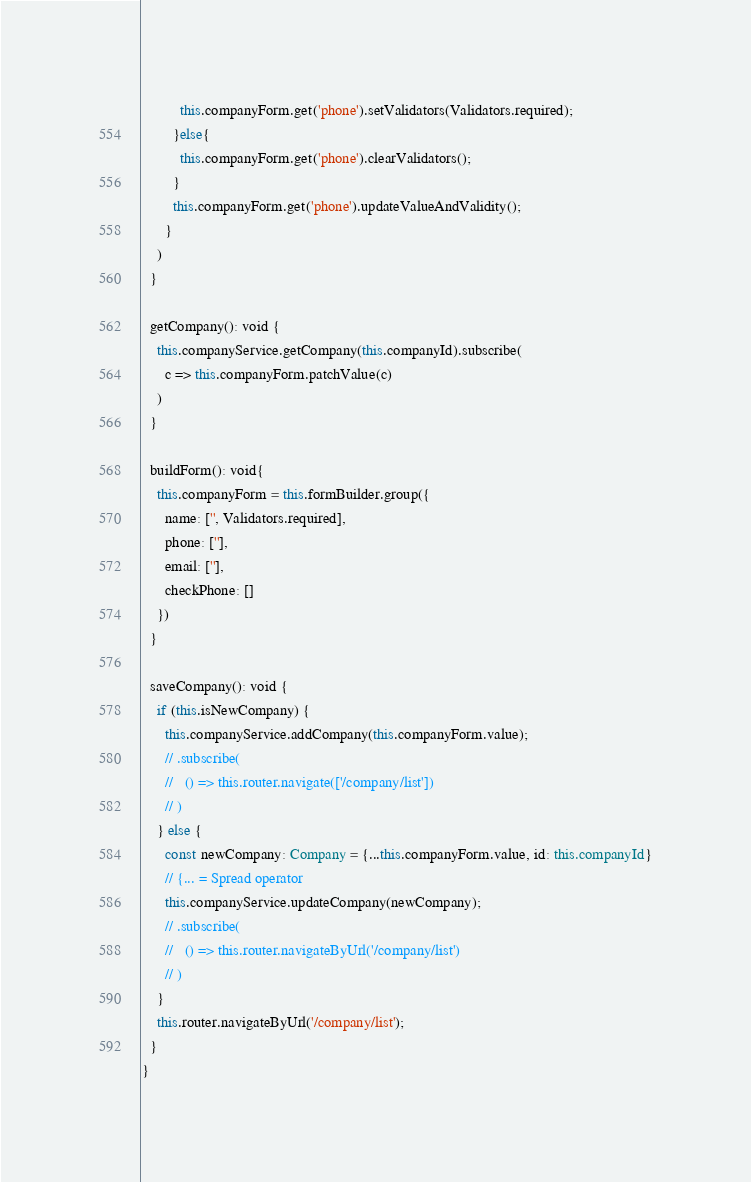<code> <loc_0><loc_0><loc_500><loc_500><_TypeScript_>          this.companyForm.get('phone').setValidators(Validators.required);
        }else{
          this.companyForm.get('phone').clearValidators();
        }
        this.companyForm.get('phone').updateValueAndValidity();
      }
    )
  }

  getCompany(): void {
    this.companyService.getCompany(this.companyId).subscribe(
      c => this.companyForm.patchValue(c)
    )
  }

  buildForm(): void{
    this.companyForm = this.formBuilder.group({
      name: ['', Validators.required],
      phone: [''],
      email: [''],
      checkPhone: []
    })
  }

  saveCompany(): void {
    if (this.isNewCompany) {
      this.companyService.addCompany(this.companyForm.value);
      // .subscribe(
      //   () => this.router.navigate(['/company/list'])
      // )
    } else {
      const newCompany: Company = {...this.companyForm.value, id: this.companyId}
      // {... = Spread operator
      this.companyService.updateCompany(newCompany);
      // .subscribe(
      //   () => this.router.navigateByUrl('/company/list')
      // )
    }
    this.router.navigateByUrl('/company/list');
  }
}
</code> 